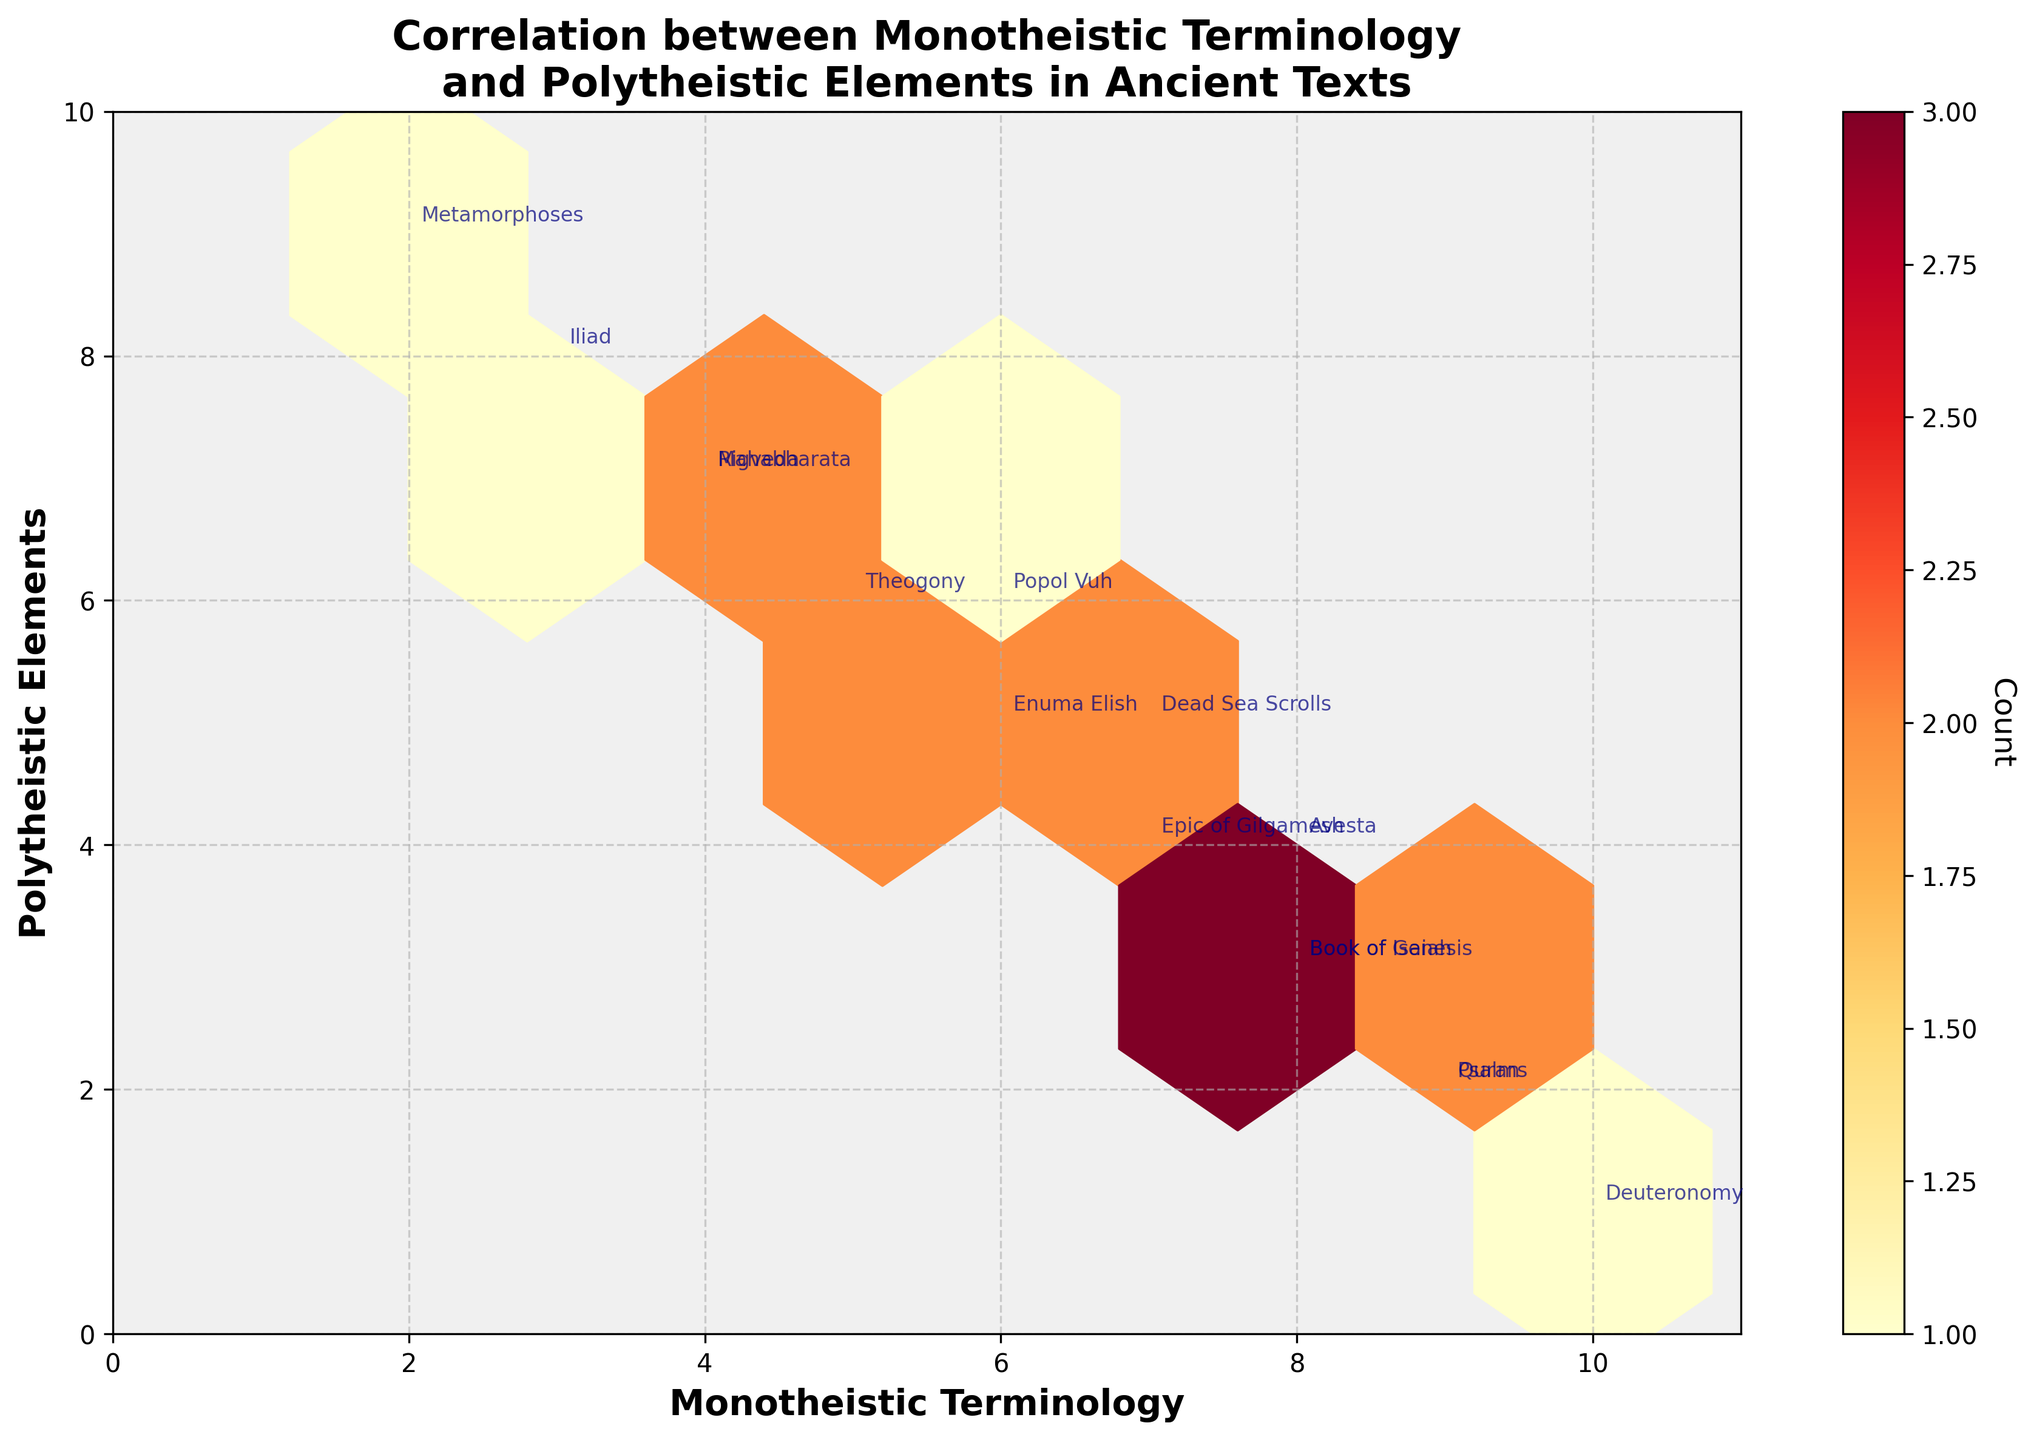What's the title of the plot? The title of the plot is clearly written at the top of the figure, providing a brief description of what the plot represents.
Answer: Correlation between Monotheistic Terminology and Polytheistic Elements in Ancient Texts What values are on the x-axis and y-axis? The x-axis and y-axis both have labeled values and ranges. The x-axis represents "Monotheistic Terminology" ranging from 0 to 11, and the y-axis represents "Polytheistic Elements" ranging from 0 to 10.
Answer: Monotheistic Terminology and Polytheistic Elements How many hexagons show the presence of texts with more than 8 uses of monotheistic terminology and less than 3 polytheistic elements? To find this, observe hexagons in the range of x > 8 and y < 3. Two texts fit this condition: Deuteronomy and Quran.
Answer: 2 Which text shows the highest presence of polytheistic elements? By looking at the y-axis, the text with the highest y value (max = 9) is Metamorphoses.
Answer: Metamorphoses Which text appears at (8, 3)? By locating the coordinates (8, 3) on the plot, you can see the annotation for the text at this position, which is the Book of Genesis.
Answer: Book of Genesis Is there a stronger presence of monotheistic terminology or polytheistic elements in the texts? To answer this qualitatively, consider the overall distribution of data points. More texts cluster towards higher x values (monotheistic terminology) compared to y values (polytheistic elements).
Answer: Monotheistic Terminology What's the median value of polytheistic elements for texts with more than 6 uses of monotheistic terminology? Identify texts with x > 6 (Book of Genesis, Psalms, Deuteronomy, Quran, Avesta), then find their y values (3, 2, 1, 2, 4). The median value of these y values is 2.
Answer: 2 Which text has the same count for both monotheistic terminology and polytheistic elements? Locate texts where the x and y values are equal. Popol Vuh sits at (6, 6).
Answer: Popol Vuh How many texts have more than 5 counts in both monotheistic terminology and polytheistic elements? Check hexagons where both x > 5 and y > 5. One text fits this condition: Popol Vuh.
Answer: 1 How does the color of hexagons represent data in this plot? The color indicates the count of data points within each hexagon, where darker shades represent a higher number of overlapping points. Refer to the color bar to see this relationship.
Answer: Darker shades indicate higher counts 